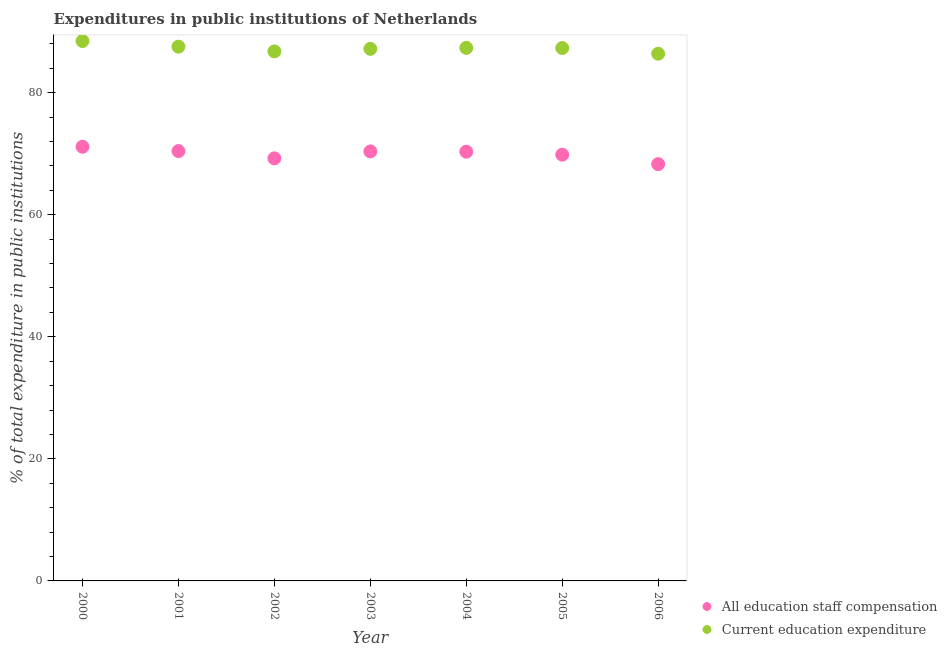Is the number of dotlines equal to the number of legend labels?
Provide a short and direct response. Yes. What is the expenditure in staff compensation in 2003?
Offer a terse response. 70.37. Across all years, what is the maximum expenditure in staff compensation?
Provide a short and direct response. 71.13. Across all years, what is the minimum expenditure in staff compensation?
Provide a succinct answer. 68.28. What is the total expenditure in education in the graph?
Your answer should be compact. 610.89. What is the difference between the expenditure in staff compensation in 2000 and that in 2006?
Keep it short and to the point. 2.85. What is the difference between the expenditure in education in 2003 and the expenditure in staff compensation in 2006?
Provide a short and direct response. 18.89. What is the average expenditure in education per year?
Ensure brevity in your answer.  87.27. In the year 2001, what is the difference between the expenditure in education and expenditure in staff compensation?
Keep it short and to the point. 17.1. What is the ratio of the expenditure in education in 2004 to that in 2006?
Offer a terse response. 1.01. Is the difference between the expenditure in education in 2003 and 2006 greater than the difference between the expenditure in staff compensation in 2003 and 2006?
Offer a very short reply. No. What is the difference between the highest and the second highest expenditure in education?
Ensure brevity in your answer.  0.93. What is the difference between the highest and the lowest expenditure in education?
Your answer should be compact. 2.08. Is the expenditure in staff compensation strictly less than the expenditure in education over the years?
Make the answer very short. Yes. How many dotlines are there?
Your answer should be compact. 2. Does the graph contain any zero values?
Your response must be concise. No. Where does the legend appear in the graph?
Give a very brief answer. Bottom right. How are the legend labels stacked?
Offer a very short reply. Vertical. What is the title of the graph?
Keep it short and to the point. Expenditures in public institutions of Netherlands. Does "Fraud firms" appear as one of the legend labels in the graph?
Your response must be concise. No. What is the label or title of the X-axis?
Offer a terse response. Year. What is the label or title of the Y-axis?
Your answer should be compact. % of total expenditure in public institutions. What is the % of total expenditure in public institutions of All education staff compensation in 2000?
Provide a succinct answer. 71.13. What is the % of total expenditure in public institutions in Current education expenditure in 2000?
Keep it short and to the point. 88.45. What is the % of total expenditure in public institutions of All education staff compensation in 2001?
Offer a very short reply. 70.42. What is the % of total expenditure in public institutions in Current education expenditure in 2001?
Your response must be concise. 87.52. What is the % of total expenditure in public institutions in All education staff compensation in 2002?
Give a very brief answer. 69.23. What is the % of total expenditure in public institutions of Current education expenditure in 2002?
Your response must be concise. 86.75. What is the % of total expenditure in public institutions of All education staff compensation in 2003?
Your response must be concise. 70.37. What is the % of total expenditure in public institutions in Current education expenditure in 2003?
Your response must be concise. 87.17. What is the % of total expenditure in public institutions in All education staff compensation in 2004?
Offer a terse response. 70.32. What is the % of total expenditure in public institutions of Current education expenditure in 2004?
Your response must be concise. 87.33. What is the % of total expenditure in public institutions in All education staff compensation in 2005?
Provide a short and direct response. 69.83. What is the % of total expenditure in public institutions in Current education expenditure in 2005?
Provide a succinct answer. 87.3. What is the % of total expenditure in public institutions in All education staff compensation in 2006?
Your answer should be very brief. 68.28. What is the % of total expenditure in public institutions of Current education expenditure in 2006?
Your answer should be very brief. 86.37. Across all years, what is the maximum % of total expenditure in public institutions in All education staff compensation?
Offer a terse response. 71.13. Across all years, what is the maximum % of total expenditure in public institutions in Current education expenditure?
Offer a terse response. 88.45. Across all years, what is the minimum % of total expenditure in public institutions in All education staff compensation?
Your answer should be compact. 68.28. Across all years, what is the minimum % of total expenditure in public institutions in Current education expenditure?
Keep it short and to the point. 86.37. What is the total % of total expenditure in public institutions in All education staff compensation in the graph?
Your answer should be compact. 489.57. What is the total % of total expenditure in public institutions in Current education expenditure in the graph?
Your answer should be compact. 610.89. What is the difference between the % of total expenditure in public institutions in All education staff compensation in 2000 and that in 2001?
Make the answer very short. 0.71. What is the difference between the % of total expenditure in public institutions of Current education expenditure in 2000 and that in 2001?
Your answer should be compact. 0.93. What is the difference between the % of total expenditure in public institutions of All education staff compensation in 2000 and that in 2002?
Your answer should be very brief. 1.9. What is the difference between the % of total expenditure in public institutions of Current education expenditure in 2000 and that in 2002?
Your answer should be very brief. 1.7. What is the difference between the % of total expenditure in public institutions in All education staff compensation in 2000 and that in 2003?
Give a very brief answer. 0.76. What is the difference between the % of total expenditure in public institutions in Current education expenditure in 2000 and that in 2003?
Make the answer very short. 1.28. What is the difference between the % of total expenditure in public institutions in All education staff compensation in 2000 and that in 2004?
Your response must be concise. 0.81. What is the difference between the % of total expenditure in public institutions in Current education expenditure in 2000 and that in 2004?
Provide a succinct answer. 1.12. What is the difference between the % of total expenditure in public institutions of All education staff compensation in 2000 and that in 2005?
Keep it short and to the point. 1.3. What is the difference between the % of total expenditure in public institutions in Current education expenditure in 2000 and that in 2005?
Offer a terse response. 1.15. What is the difference between the % of total expenditure in public institutions of All education staff compensation in 2000 and that in 2006?
Your answer should be very brief. 2.85. What is the difference between the % of total expenditure in public institutions in Current education expenditure in 2000 and that in 2006?
Your answer should be very brief. 2.08. What is the difference between the % of total expenditure in public institutions of All education staff compensation in 2001 and that in 2002?
Give a very brief answer. 1.19. What is the difference between the % of total expenditure in public institutions in Current education expenditure in 2001 and that in 2002?
Keep it short and to the point. 0.77. What is the difference between the % of total expenditure in public institutions in All education staff compensation in 2001 and that in 2003?
Make the answer very short. 0.05. What is the difference between the % of total expenditure in public institutions in Current education expenditure in 2001 and that in 2003?
Give a very brief answer. 0.36. What is the difference between the % of total expenditure in public institutions in All education staff compensation in 2001 and that in 2004?
Your response must be concise. 0.1. What is the difference between the % of total expenditure in public institutions of Current education expenditure in 2001 and that in 2004?
Your answer should be compact. 0.19. What is the difference between the % of total expenditure in public institutions of All education staff compensation in 2001 and that in 2005?
Provide a short and direct response. 0.59. What is the difference between the % of total expenditure in public institutions of Current education expenditure in 2001 and that in 2005?
Provide a short and direct response. 0.22. What is the difference between the % of total expenditure in public institutions of All education staff compensation in 2001 and that in 2006?
Your answer should be compact. 2.14. What is the difference between the % of total expenditure in public institutions in Current education expenditure in 2001 and that in 2006?
Your answer should be compact. 1.15. What is the difference between the % of total expenditure in public institutions of All education staff compensation in 2002 and that in 2003?
Keep it short and to the point. -1.14. What is the difference between the % of total expenditure in public institutions in Current education expenditure in 2002 and that in 2003?
Give a very brief answer. -0.41. What is the difference between the % of total expenditure in public institutions of All education staff compensation in 2002 and that in 2004?
Your response must be concise. -1.09. What is the difference between the % of total expenditure in public institutions of Current education expenditure in 2002 and that in 2004?
Provide a succinct answer. -0.57. What is the difference between the % of total expenditure in public institutions of All education staff compensation in 2002 and that in 2005?
Your answer should be compact. -0.6. What is the difference between the % of total expenditure in public institutions of Current education expenditure in 2002 and that in 2005?
Your response must be concise. -0.55. What is the difference between the % of total expenditure in public institutions of All education staff compensation in 2002 and that in 2006?
Your response must be concise. 0.95. What is the difference between the % of total expenditure in public institutions in Current education expenditure in 2002 and that in 2006?
Provide a short and direct response. 0.39. What is the difference between the % of total expenditure in public institutions in All education staff compensation in 2003 and that in 2004?
Make the answer very short. 0.05. What is the difference between the % of total expenditure in public institutions of Current education expenditure in 2003 and that in 2004?
Ensure brevity in your answer.  -0.16. What is the difference between the % of total expenditure in public institutions in All education staff compensation in 2003 and that in 2005?
Your answer should be compact. 0.54. What is the difference between the % of total expenditure in public institutions of Current education expenditure in 2003 and that in 2005?
Ensure brevity in your answer.  -0.13. What is the difference between the % of total expenditure in public institutions of All education staff compensation in 2003 and that in 2006?
Your response must be concise. 2.08. What is the difference between the % of total expenditure in public institutions of Current education expenditure in 2003 and that in 2006?
Give a very brief answer. 0.8. What is the difference between the % of total expenditure in public institutions of All education staff compensation in 2004 and that in 2005?
Make the answer very short. 0.49. What is the difference between the % of total expenditure in public institutions of Current education expenditure in 2004 and that in 2005?
Give a very brief answer. 0.03. What is the difference between the % of total expenditure in public institutions in All education staff compensation in 2004 and that in 2006?
Provide a short and direct response. 2.04. What is the difference between the % of total expenditure in public institutions in Current education expenditure in 2004 and that in 2006?
Give a very brief answer. 0.96. What is the difference between the % of total expenditure in public institutions in All education staff compensation in 2005 and that in 2006?
Give a very brief answer. 1.54. What is the difference between the % of total expenditure in public institutions in Current education expenditure in 2005 and that in 2006?
Your answer should be compact. 0.93. What is the difference between the % of total expenditure in public institutions in All education staff compensation in 2000 and the % of total expenditure in public institutions in Current education expenditure in 2001?
Offer a terse response. -16.39. What is the difference between the % of total expenditure in public institutions of All education staff compensation in 2000 and the % of total expenditure in public institutions of Current education expenditure in 2002?
Keep it short and to the point. -15.63. What is the difference between the % of total expenditure in public institutions in All education staff compensation in 2000 and the % of total expenditure in public institutions in Current education expenditure in 2003?
Offer a terse response. -16.04. What is the difference between the % of total expenditure in public institutions of All education staff compensation in 2000 and the % of total expenditure in public institutions of Current education expenditure in 2004?
Make the answer very short. -16.2. What is the difference between the % of total expenditure in public institutions in All education staff compensation in 2000 and the % of total expenditure in public institutions in Current education expenditure in 2005?
Offer a very short reply. -16.17. What is the difference between the % of total expenditure in public institutions of All education staff compensation in 2000 and the % of total expenditure in public institutions of Current education expenditure in 2006?
Offer a terse response. -15.24. What is the difference between the % of total expenditure in public institutions of All education staff compensation in 2001 and the % of total expenditure in public institutions of Current education expenditure in 2002?
Provide a succinct answer. -16.34. What is the difference between the % of total expenditure in public institutions in All education staff compensation in 2001 and the % of total expenditure in public institutions in Current education expenditure in 2003?
Ensure brevity in your answer.  -16.75. What is the difference between the % of total expenditure in public institutions in All education staff compensation in 2001 and the % of total expenditure in public institutions in Current education expenditure in 2004?
Ensure brevity in your answer.  -16.91. What is the difference between the % of total expenditure in public institutions of All education staff compensation in 2001 and the % of total expenditure in public institutions of Current education expenditure in 2005?
Provide a succinct answer. -16.88. What is the difference between the % of total expenditure in public institutions of All education staff compensation in 2001 and the % of total expenditure in public institutions of Current education expenditure in 2006?
Your answer should be compact. -15.95. What is the difference between the % of total expenditure in public institutions of All education staff compensation in 2002 and the % of total expenditure in public institutions of Current education expenditure in 2003?
Provide a succinct answer. -17.94. What is the difference between the % of total expenditure in public institutions of All education staff compensation in 2002 and the % of total expenditure in public institutions of Current education expenditure in 2004?
Give a very brief answer. -18.1. What is the difference between the % of total expenditure in public institutions of All education staff compensation in 2002 and the % of total expenditure in public institutions of Current education expenditure in 2005?
Keep it short and to the point. -18.07. What is the difference between the % of total expenditure in public institutions of All education staff compensation in 2002 and the % of total expenditure in public institutions of Current education expenditure in 2006?
Make the answer very short. -17.14. What is the difference between the % of total expenditure in public institutions in All education staff compensation in 2003 and the % of total expenditure in public institutions in Current education expenditure in 2004?
Your answer should be very brief. -16.96. What is the difference between the % of total expenditure in public institutions in All education staff compensation in 2003 and the % of total expenditure in public institutions in Current education expenditure in 2005?
Your answer should be very brief. -16.93. What is the difference between the % of total expenditure in public institutions in All education staff compensation in 2003 and the % of total expenditure in public institutions in Current education expenditure in 2006?
Your answer should be compact. -16. What is the difference between the % of total expenditure in public institutions in All education staff compensation in 2004 and the % of total expenditure in public institutions in Current education expenditure in 2005?
Your response must be concise. -16.98. What is the difference between the % of total expenditure in public institutions of All education staff compensation in 2004 and the % of total expenditure in public institutions of Current education expenditure in 2006?
Keep it short and to the point. -16.05. What is the difference between the % of total expenditure in public institutions of All education staff compensation in 2005 and the % of total expenditure in public institutions of Current education expenditure in 2006?
Offer a terse response. -16.54. What is the average % of total expenditure in public institutions of All education staff compensation per year?
Offer a terse response. 69.94. What is the average % of total expenditure in public institutions of Current education expenditure per year?
Your answer should be very brief. 87.27. In the year 2000, what is the difference between the % of total expenditure in public institutions in All education staff compensation and % of total expenditure in public institutions in Current education expenditure?
Your answer should be very brief. -17.32. In the year 2001, what is the difference between the % of total expenditure in public institutions in All education staff compensation and % of total expenditure in public institutions in Current education expenditure?
Your response must be concise. -17.1. In the year 2002, what is the difference between the % of total expenditure in public institutions in All education staff compensation and % of total expenditure in public institutions in Current education expenditure?
Ensure brevity in your answer.  -17.52. In the year 2003, what is the difference between the % of total expenditure in public institutions in All education staff compensation and % of total expenditure in public institutions in Current education expenditure?
Keep it short and to the point. -16.8. In the year 2004, what is the difference between the % of total expenditure in public institutions of All education staff compensation and % of total expenditure in public institutions of Current education expenditure?
Provide a succinct answer. -17.01. In the year 2005, what is the difference between the % of total expenditure in public institutions in All education staff compensation and % of total expenditure in public institutions in Current education expenditure?
Ensure brevity in your answer.  -17.47. In the year 2006, what is the difference between the % of total expenditure in public institutions of All education staff compensation and % of total expenditure in public institutions of Current education expenditure?
Your answer should be very brief. -18.09. What is the ratio of the % of total expenditure in public institutions of All education staff compensation in 2000 to that in 2001?
Give a very brief answer. 1.01. What is the ratio of the % of total expenditure in public institutions of Current education expenditure in 2000 to that in 2001?
Offer a terse response. 1.01. What is the ratio of the % of total expenditure in public institutions of All education staff compensation in 2000 to that in 2002?
Offer a very short reply. 1.03. What is the ratio of the % of total expenditure in public institutions in Current education expenditure in 2000 to that in 2002?
Keep it short and to the point. 1.02. What is the ratio of the % of total expenditure in public institutions of All education staff compensation in 2000 to that in 2003?
Ensure brevity in your answer.  1.01. What is the ratio of the % of total expenditure in public institutions of Current education expenditure in 2000 to that in 2003?
Provide a succinct answer. 1.01. What is the ratio of the % of total expenditure in public institutions of All education staff compensation in 2000 to that in 2004?
Offer a very short reply. 1.01. What is the ratio of the % of total expenditure in public institutions of Current education expenditure in 2000 to that in 2004?
Ensure brevity in your answer.  1.01. What is the ratio of the % of total expenditure in public institutions of All education staff compensation in 2000 to that in 2005?
Offer a very short reply. 1.02. What is the ratio of the % of total expenditure in public institutions in Current education expenditure in 2000 to that in 2005?
Ensure brevity in your answer.  1.01. What is the ratio of the % of total expenditure in public institutions in All education staff compensation in 2000 to that in 2006?
Your answer should be compact. 1.04. What is the ratio of the % of total expenditure in public institutions of Current education expenditure in 2000 to that in 2006?
Make the answer very short. 1.02. What is the ratio of the % of total expenditure in public institutions in All education staff compensation in 2001 to that in 2002?
Give a very brief answer. 1.02. What is the ratio of the % of total expenditure in public institutions in Current education expenditure in 2001 to that in 2002?
Make the answer very short. 1.01. What is the ratio of the % of total expenditure in public institutions of All education staff compensation in 2001 to that in 2005?
Your answer should be very brief. 1.01. What is the ratio of the % of total expenditure in public institutions in All education staff compensation in 2001 to that in 2006?
Your response must be concise. 1.03. What is the ratio of the % of total expenditure in public institutions of Current education expenditure in 2001 to that in 2006?
Your response must be concise. 1.01. What is the ratio of the % of total expenditure in public institutions in All education staff compensation in 2002 to that in 2003?
Your response must be concise. 0.98. What is the ratio of the % of total expenditure in public institutions of All education staff compensation in 2002 to that in 2004?
Make the answer very short. 0.98. What is the ratio of the % of total expenditure in public institutions in All education staff compensation in 2002 to that in 2006?
Your answer should be compact. 1.01. What is the ratio of the % of total expenditure in public institutions of Current education expenditure in 2002 to that in 2006?
Offer a very short reply. 1. What is the ratio of the % of total expenditure in public institutions in All education staff compensation in 2003 to that in 2005?
Keep it short and to the point. 1.01. What is the ratio of the % of total expenditure in public institutions in All education staff compensation in 2003 to that in 2006?
Your answer should be very brief. 1.03. What is the ratio of the % of total expenditure in public institutions in Current education expenditure in 2003 to that in 2006?
Provide a succinct answer. 1.01. What is the ratio of the % of total expenditure in public institutions of All education staff compensation in 2004 to that in 2005?
Provide a succinct answer. 1.01. What is the ratio of the % of total expenditure in public institutions in Current education expenditure in 2004 to that in 2005?
Your response must be concise. 1. What is the ratio of the % of total expenditure in public institutions of All education staff compensation in 2004 to that in 2006?
Make the answer very short. 1.03. What is the ratio of the % of total expenditure in public institutions of Current education expenditure in 2004 to that in 2006?
Your answer should be very brief. 1.01. What is the ratio of the % of total expenditure in public institutions in All education staff compensation in 2005 to that in 2006?
Provide a short and direct response. 1.02. What is the ratio of the % of total expenditure in public institutions of Current education expenditure in 2005 to that in 2006?
Give a very brief answer. 1.01. What is the difference between the highest and the second highest % of total expenditure in public institutions in All education staff compensation?
Give a very brief answer. 0.71. What is the difference between the highest and the second highest % of total expenditure in public institutions of Current education expenditure?
Offer a very short reply. 0.93. What is the difference between the highest and the lowest % of total expenditure in public institutions of All education staff compensation?
Offer a very short reply. 2.85. What is the difference between the highest and the lowest % of total expenditure in public institutions of Current education expenditure?
Make the answer very short. 2.08. 